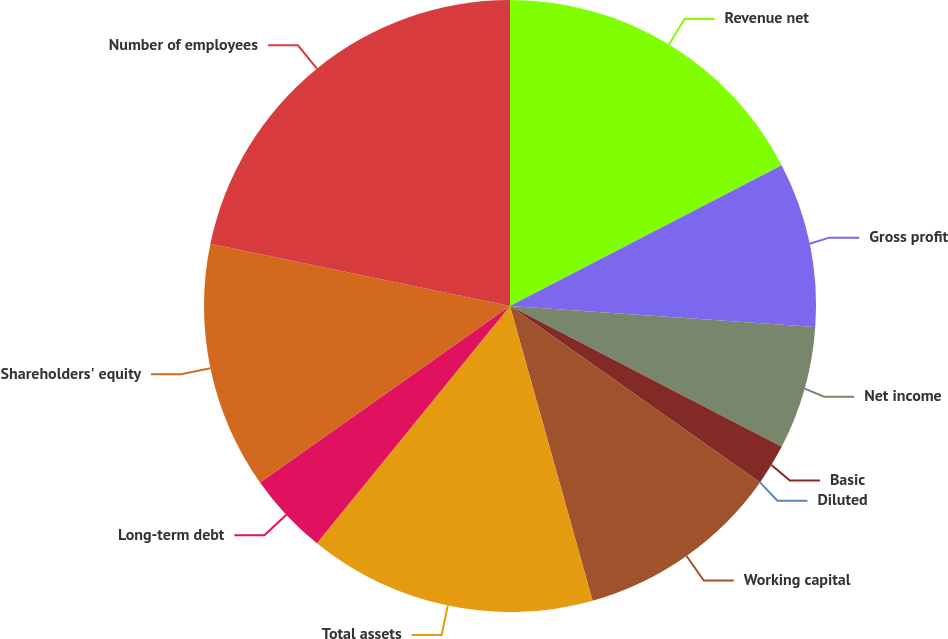Convert chart. <chart><loc_0><loc_0><loc_500><loc_500><pie_chart><fcel>Revenue net<fcel>Gross profit<fcel>Net income<fcel>Basic<fcel>Diluted<fcel>Working capital<fcel>Total assets<fcel>Long-term debt<fcel>Shareholders' equity<fcel>Number of employees<nl><fcel>17.39%<fcel>8.7%<fcel>6.52%<fcel>2.17%<fcel>0.0%<fcel>10.87%<fcel>15.22%<fcel>4.35%<fcel>13.04%<fcel>21.74%<nl></chart> 